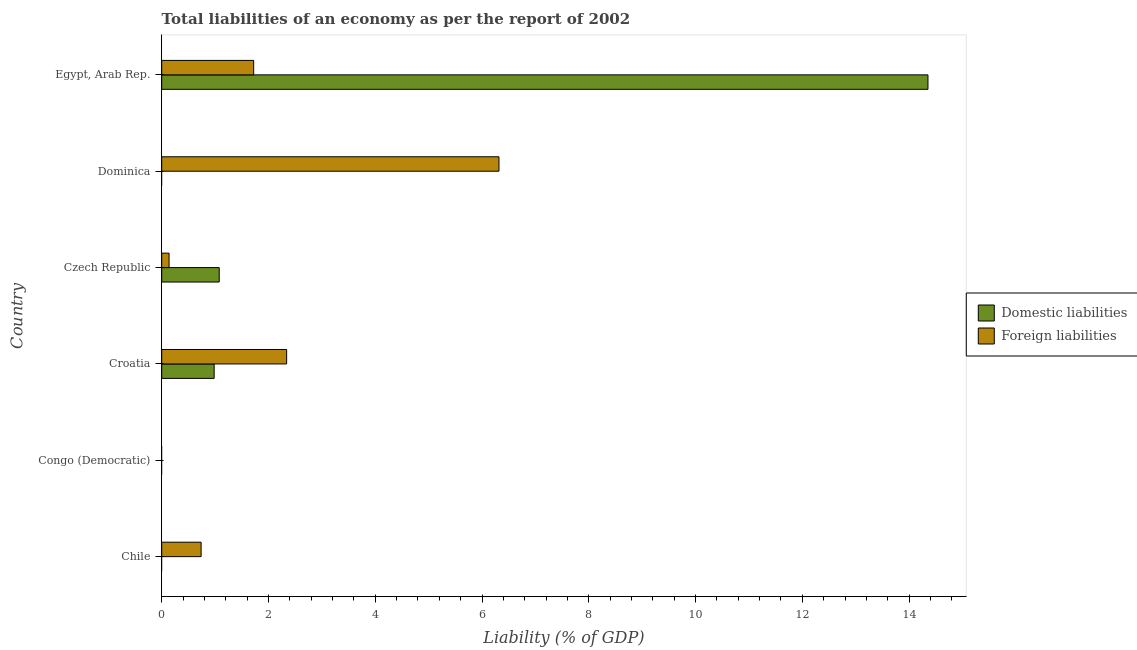How many different coloured bars are there?
Make the answer very short. 2. Are the number of bars on each tick of the Y-axis equal?
Offer a very short reply. No. How many bars are there on the 2nd tick from the top?
Give a very brief answer. 1. What is the label of the 4th group of bars from the top?
Keep it short and to the point. Croatia. What is the incurrence of domestic liabilities in Czech Republic?
Provide a succinct answer. 1.08. Across all countries, what is the maximum incurrence of domestic liabilities?
Keep it short and to the point. 14.35. In which country was the incurrence of foreign liabilities maximum?
Keep it short and to the point. Dominica. What is the total incurrence of domestic liabilities in the graph?
Keep it short and to the point. 16.41. What is the difference between the incurrence of foreign liabilities in Dominica and that in Egypt, Arab Rep.?
Give a very brief answer. 4.59. What is the difference between the incurrence of foreign liabilities in Croatia and the incurrence of domestic liabilities in Chile?
Offer a terse response. 2.34. What is the average incurrence of foreign liabilities per country?
Offer a very short reply. 1.88. What is the difference between the incurrence of foreign liabilities and incurrence of domestic liabilities in Czech Republic?
Provide a succinct answer. -0.94. What is the ratio of the incurrence of domestic liabilities in Czech Republic to that in Egypt, Arab Rep.?
Your answer should be compact. 0.07. What is the difference between the highest and the second highest incurrence of foreign liabilities?
Provide a short and direct response. 3.98. What is the difference between the highest and the lowest incurrence of foreign liabilities?
Ensure brevity in your answer.  6.32. How many bars are there?
Make the answer very short. 8. What is the difference between two consecutive major ticks on the X-axis?
Your response must be concise. 2. Are the values on the major ticks of X-axis written in scientific E-notation?
Your answer should be very brief. No. Does the graph contain any zero values?
Keep it short and to the point. Yes. Where does the legend appear in the graph?
Your response must be concise. Center right. How are the legend labels stacked?
Provide a succinct answer. Vertical. What is the title of the graph?
Ensure brevity in your answer.  Total liabilities of an economy as per the report of 2002. Does "Taxes" appear as one of the legend labels in the graph?
Provide a short and direct response. No. What is the label or title of the X-axis?
Offer a very short reply. Liability (% of GDP). What is the Liability (% of GDP) of Domestic liabilities in Chile?
Make the answer very short. 0. What is the Liability (% of GDP) in Foreign liabilities in Chile?
Provide a succinct answer. 0.74. What is the Liability (% of GDP) of Domestic liabilities in Congo (Democratic)?
Keep it short and to the point. 0. What is the Liability (% of GDP) in Domestic liabilities in Croatia?
Offer a terse response. 0.98. What is the Liability (% of GDP) in Foreign liabilities in Croatia?
Your answer should be compact. 2.34. What is the Liability (% of GDP) in Domestic liabilities in Czech Republic?
Make the answer very short. 1.08. What is the Liability (% of GDP) in Foreign liabilities in Czech Republic?
Your answer should be very brief. 0.14. What is the Liability (% of GDP) of Domestic liabilities in Dominica?
Your answer should be compact. 0. What is the Liability (% of GDP) of Foreign liabilities in Dominica?
Make the answer very short. 6.32. What is the Liability (% of GDP) in Domestic liabilities in Egypt, Arab Rep.?
Your answer should be compact. 14.35. What is the Liability (% of GDP) in Foreign liabilities in Egypt, Arab Rep.?
Offer a very short reply. 1.72. Across all countries, what is the maximum Liability (% of GDP) in Domestic liabilities?
Keep it short and to the point. 14.35. Across all countries, what is the maximum Liability (% of GDP) of Foreign liabilities?
Make the answer very short. 6.32. What is the total Liability (% of GDP) in Domestic liabilities in the graph?
Offer a terse response. 16.41. What is the total Liability (% of GDP) of Foreign liabilities in the graph?
Your answer should be compact. 11.26. What is the difference between the Liability (% of GDP) of Foreign liabilities in Chile and that in Croatia?
Ensure brevity in your answer.  -1.6. What is the difference between the Liability (% of GDP) of Foreign liabilities in Chile and that in Czech Republic?
Provide a short and direct response. 0.6. What is the difference between the Liability (% of GDP) in Foreign liabilities in Chile and that in Dominica?
Make the answer very short. -5.58. What is the difference between the Liability (% of GDP) of Foreign liabilities in Chile and that in Egypt, Arab Rep.?
Ensure brevity in your answer.  -0.98. What is the difference between the Liability (% of GDP) in Domestic liabilities in Croatia and that in Czech Republic?
Ensure brevity in your answer.  -0.09. What is the difference between the Liability (% of GDP) of Foreign liabilities in Croatia and that in Czech Republic?
Make the answer very short. 2.2. What is the difference between the Liability (% of GDP) of Foreign liabilities in Croatia and that in Dominica?
Your answer should be compact. -3.98. What is the difference between the Liability (% of GDP) of Domestic liabilities in Croatia and that in Egypt, Arab Rep.?
Offer a very short reply. -13.37. What is the difference between the Liability (% of GDP) of Foreign liabilities in Croatia and that in Egypt, Arab Rep.?
Your answer should be very brief. 0.62. What is the difference between the Liability (% of GDP) in Foreign liabilities in Czech Republic and that in Dominica?
Offer a terse response. -6.18. What is the difference between the Liability (% of GDP) of Domestic liabilities in Czech Republic and that in Egypt, Arab Rep.?
Keep it short and to the point. -13.28. What is the difference between the Liability (% of GDP) in Foreign liabilities in Czech Republic and that in Egypt, Arab Rep.?
Make the answer very short. -1.58. What is the difference between the Liability (% of GDP) in Foreign liabilities in Dominica and that in Egypt, Arab Rep.?
Provide a short and direct response. 4.59. What is the difference between the Liability (% of GDP) of Domestic liabilities in Croatia and the Liability (% of GDP) of Foreign liabilities in Czech Republic?
Your response must be concise. 0.84. What is the difference between the Liability (% of GDP) of Domestic liabilities in Croatia and the Liability (% of GDP) of Foreign liabilities in Dominica?
Offer a very short reply. -5.33. What is the difference between the Liability (% of GDP) of Domestic liabilities in Croatia and the Liability (% of GDP) of Foreign liabilities in Egypt, Arab Rep.?
Your answer should be very brief. -0.74. What is the difference between the Liability (% of GDP) of Domestic liabilities in Czech Republic and the Liability (% of GDP) of Foreign liabilities in Dominica?
Offer a terse response. -5.24. What is the difference between the Liability (% of GDP) in Domestic liabilities in Czech Republic and the Liability (% of GDP) in Foreign liabilities in Egypt, Arab Rep.?
Ensure brevity in your answer.  -0.65. What is the average Liability (% of GDP) in Domestic liabilities per country?
Ensure brevity in your answer.  2.74. What is the average Liability (% of GDP) of Foreign liabilities per country?
Provide a short and direct response. 1.88. What is the difference between the Liability (% of GDP) of Domestic liabilities and Liability (% of GDP) of Foreign liabilities in Croatia?
Your answer should be very brief. -1.36. What is the difference between the Liability (% of GDP) of Domestic liabilities and Liability (% of GDP) of Foreign liabilities in Czech Republic?
Your response must be concise. 0.94. What is the difference between the Liability (% of GDP) of Domestic liabilities and Liability (% of GDP) of Foreign liabilities in Egypt, Arab Rep.?
Offer a very short reply. 12.63. What is the ratio of the Liability (% of GDP) in Foreign liabilities in Chile to that in Croatia?
Your answer should be very brief. 0.32. What is the ratio of the Liability (% of GDP) in Foreign liabilities in Chile to that in Czech Republic?
Give a very brief answer. 5.36. What is the ratio of the Liability (% of GDP) in Foreign liabilities in Chile to that in Dominica?
Provide a short and direct response. 0.12. What is the ratio of the Liability (% of GDP) of Foreign liabilities in Chile to that in Egypt, Arab Rep.?
Your answer should be compact. 0.43. What is the ratio of the Liability (% of GDP) of Domestic liabilities in Croatia to that in Czech Republic?
Offer a very short reply. 0.91. What is the ratio of the Liability (% of GDP) in Foreign liabilities in Croatia to that in Czech Republic?
Offer a very short reply. 17. What is the ratio of the Liability (% of GDP) in Foreign liabilities in Croatia to that in Dominica?
Make the answer very short. 0.37. What is the ratio of the Liability (% of GDP) of Domestic liabilities in Croatia to that in Egypt, Arab Rep.?
Keep it short and to the point. 0.07. What is the ratio of the Liability (% of GDP) of Foreign liabilities in Croatia to that in Egypt, Arab Rep.?
Offer a terse response. 1.36. What is the ratio of the Liability (% of GDP) of Foreign liabilities in Czech Republic to that in Dominica?
Provide a succinct answer. 0.02. What is the ratio of the Liability (% of GDP) in Domestic liabilities in Czech Republic to that in Egypt, Arab Rep.?
Keep it short and to the point. 0.08. What is the ratio of the Liability (% of GDP) in Foreign liabilities in Czech Republic to that in Egypt, Arab Rep.?
Your response must be concise. 0.08. What is the ratio of the Liability (% of GDP) of Foreign liabilities in Dominica to that in Egypt, Arab Rep.?
Your answer should be compact. 3.67. What is the difference between the highest and the second highest Liability (% of GDP) in Domestic liabilities?
Keep it short and to the point. 13.28. What is the difference between the highest and the second highest Liability (% of GDP) in Foreign liabilities?
Ensure brevity in your answer.  3.98. What is the difference between the highest and the lowest Liability (% of GDP) in Domestic liabilities?
Provide a short and direct response. 14.35. What is the difference between the highest and the lowest Liability (% of GDP) in Foreign liabilities?
Ensure brevity in your answer.  6.32. 